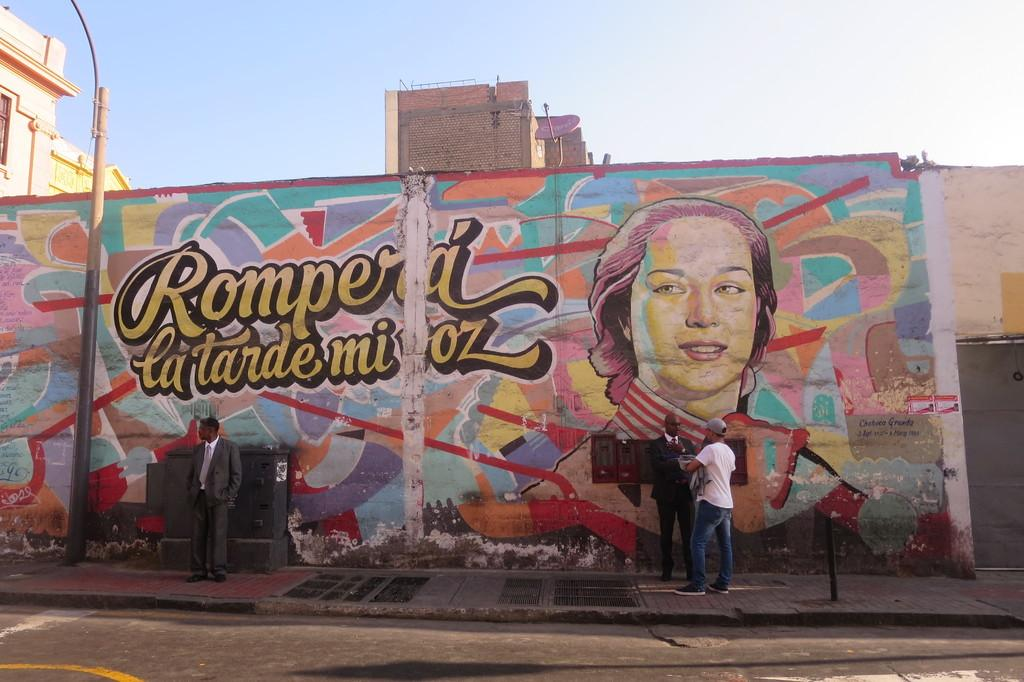What can be seen in the image? There are people standing in the image, wearing clothes and shoes. What is on the wall in the image? There is a painting on the wall in the image. What other objects or structures are present in the image? There is a pole, a road, and a wall in the image. What is visible in the background of the image? The sky is visible in the image. What story is being told by the person's knee in the image? There is no person's knee telling a story in the image, as the facts provided do not mention any knees or stories. 